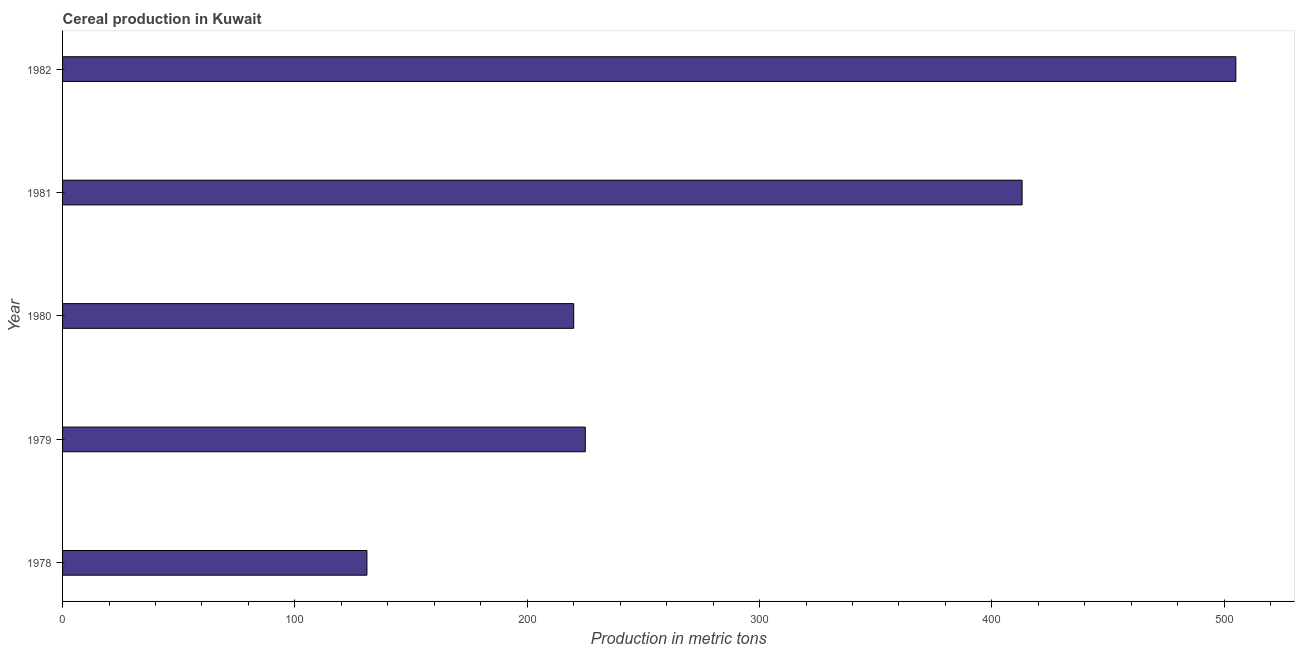What is the title of the graph?
Give a very brief answer. Cereal production in Kuwait. What is the label or title of the X-axis?
Your answer should be very brief. Production in metric tons. What is the cereal production in 1982?
Your response must be concise. 505. Across all years, what is the maximum cereal production?
Provide a succinct answer. 505. Across all years, what is the minimum cereal production?
Provide a succinct answer. 131. In which year was the cereal production maximum?
Make the answer very short. 1982. In which year was the cereal production minimum?
Keep it short and to the point. 1978. What is the sum of the cereal production?
Offer a very short reply. 1494. What is the difference between the cereal production in 1979 and 1980?
Ensure brevity in your answer.  5. What is the average cereal production per year?
Keep it short and to the point. 298.8. What is the median cereal production?
Offer a terse response. 225. Do a majority of the years between 1982 and 1980 (inclusive) have cereal production greater than 220 metric tons?
Provide a succinct answer. Yes. What is the ratio of the cereal production in 1981 to that in 1982?
Offer a terse response. 0.82. What is the difference between the highest and the second highest cereal production?
Your answer should be very brief. 92. Is the sum of the cereal production in 1978 and 1979 greater than the maximum cereal production across all years?
Provide a succinct answer. No. What is the difference between the highest and the lowest cereal production?
Offer a very short reply. 374. Are all the bars in the graph horizontal?
Offer a terse response. Yes. How many years are there in the graph?
Make the answer very short. 5. What is the difference between two consecutive major ticks on the X-axis?
Your answer should be compact. 100. Are the values on the major ticks of X-axis written in scientific E-notation?
Provide a short and direct response. No. What is the Production in metric tons of 1978?
Ensure brevity in your answer.  131. What is the Production in metric tons in 1979?
Give a very brief answer. 225. What is the Production in metric tons in 1980?
Offer a very short reply. 220. What is the Production in metric tons in 1981?
Offer a very short reply. 413. What is the Production in metric tons of 1982?
Provide a succinct answer. 505. What is the difference between the Production in metric tons in 1978 and 1979?
Offer a terse response. -94. What is the difference between the Production in metric tons in 1978 and 1980?
Provide a short and direct response. -89. What is the difference between the Production in metric tons in 1978 and 1981?
Make the answer very short. -282. What is the difference between the Production in metric tons in 1978 and 1982?
Give a very brief answer. -374. What is the difference between the Production in metric tons in 1979 and 1980?
Your answer should be very brief. 5. What is the difference between the Production in metric tons in 1979 and 1981?
Keep it short and to the point. -188. What is the difference between the Production in metric tons in 1979 and 1982?
Your response must be concise. -280. What is the difference between the Production in metric tons in 1980 and 1981?
Your response must be concise. -193. What is the difference between the Production in metric tons in 1980 and 1982?
Offer a terse response. -285. What is the difference between the Production in metric tons in 1981 and 1982?
Ensure brevity in your answer.  -92. What is the ratio of the Production in metric tons in 1978 to that in 1979?
Your response must be concise. 0.58. What is the ratio of the Production in metric tons in 1978 to that in 1980?
Offer a very short reply. 0.59. What is the ratio of the Production in metric tons in 1978 to that in 1981?
Offer a very short reply. 0.32. What is the ratio of the Production in metric tons in 1978 to that in 1982?
Keep it short and to the point. 0.26. What is the ratio of the Production in metric tons in 1979 to that in 1980?
Provide a short and direct response. 1.02. What is the ratio of the Production in metric tons in 1979 to that in 1981?
Offer a terse response. 0.55. What is the ratio of the Production in metric tons in 1979 to that in 1982?
Your answer should be compact. 0.45. What is the ratio of the Production in metric tons in 1980 to that in 1981?
Your response must be concise. 0.53. What is the ratio of the Production in metric tons in 1980 to that in 1982?
Provide a succinct answer. 0.44. What is the ratio of the Production in metric tons in 1981 to that in 1982?
Your answer should be very brief. 0.82. 